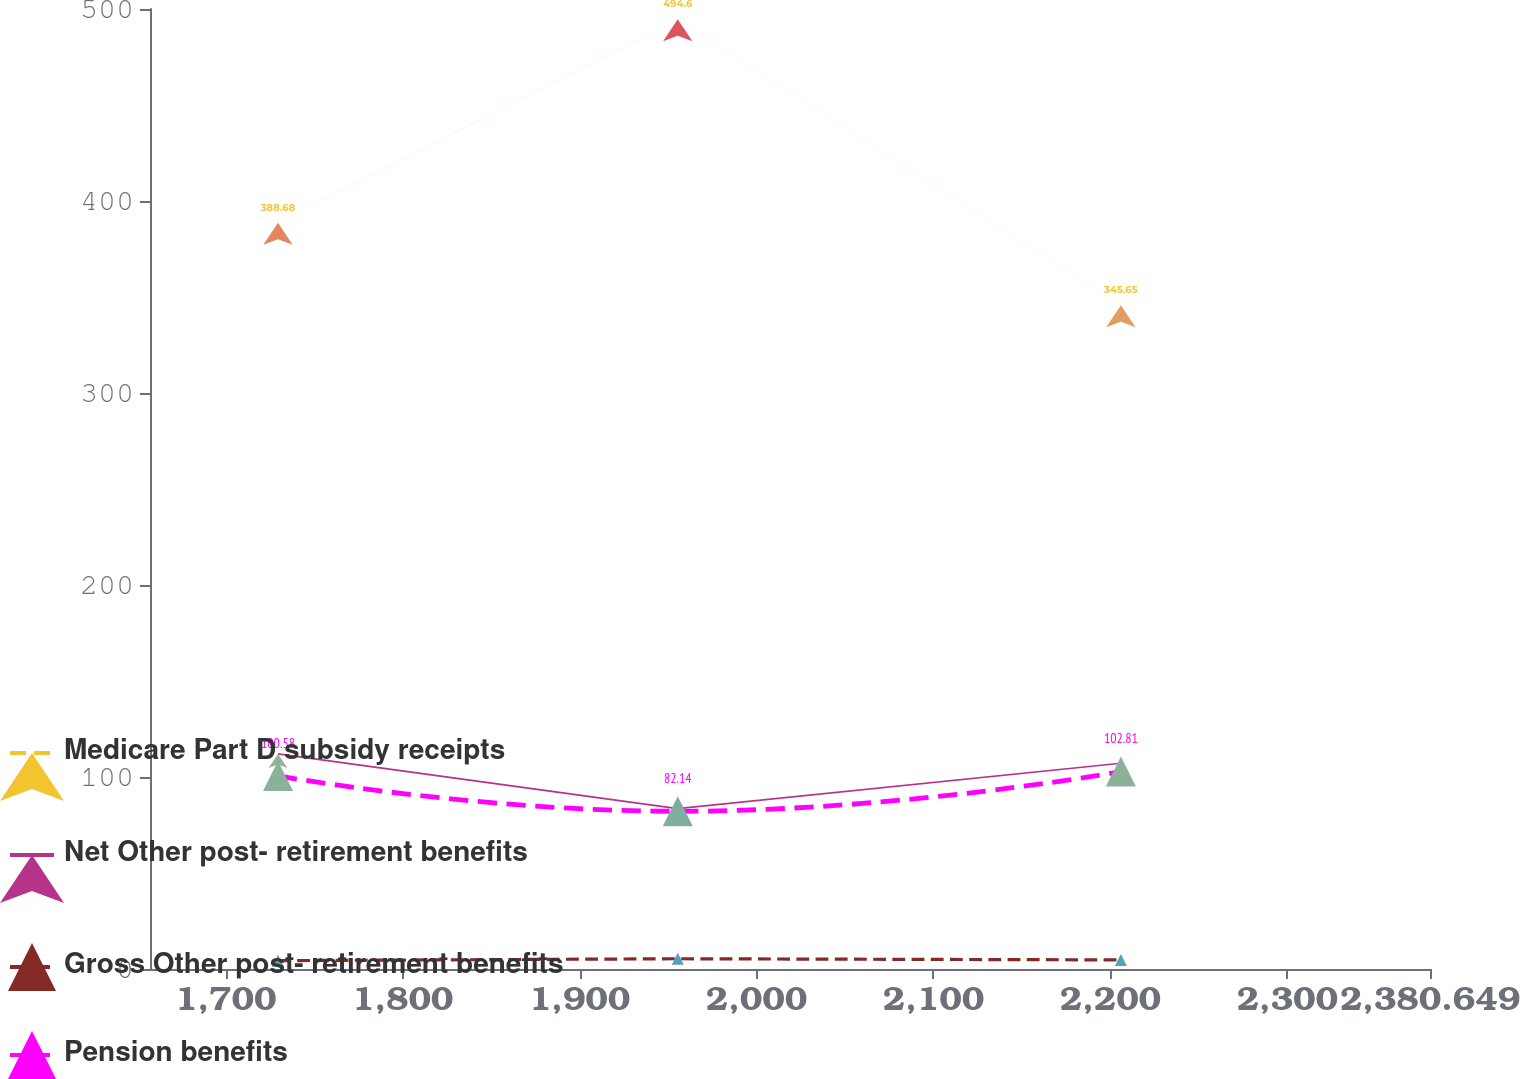Convert chart. <chart><loc_0><loc_0><loc_500><loc_500><line_chart><ecel><fcel>Medicare Part D subsidy receipts<fcel>Net Other post- retirement benefits<fcel>Gross Other post- retirement benefits<fcel>Pension benefits<nl><fcel>1729.58<fcel>388.68<fcel>112.03<fcel>4.36<fcel>100.58<nl><fcel>1955.51<fcel>494.6<fcel>83.53<fcel>5.34<fcel>82.14<nl><fcel>2205.95<fcel>345.65<fcel>107.15<fcel>4.74<fcel>102.81<nl><fcel>2385.17<fcel>440.05<fcel>86.38<fcel>4.25<fcel>97.26<nl><fcel>2452.99<fcel>509.79<fcel>104.3<fcel>4.94<fcel>79.79<nl></chart> 